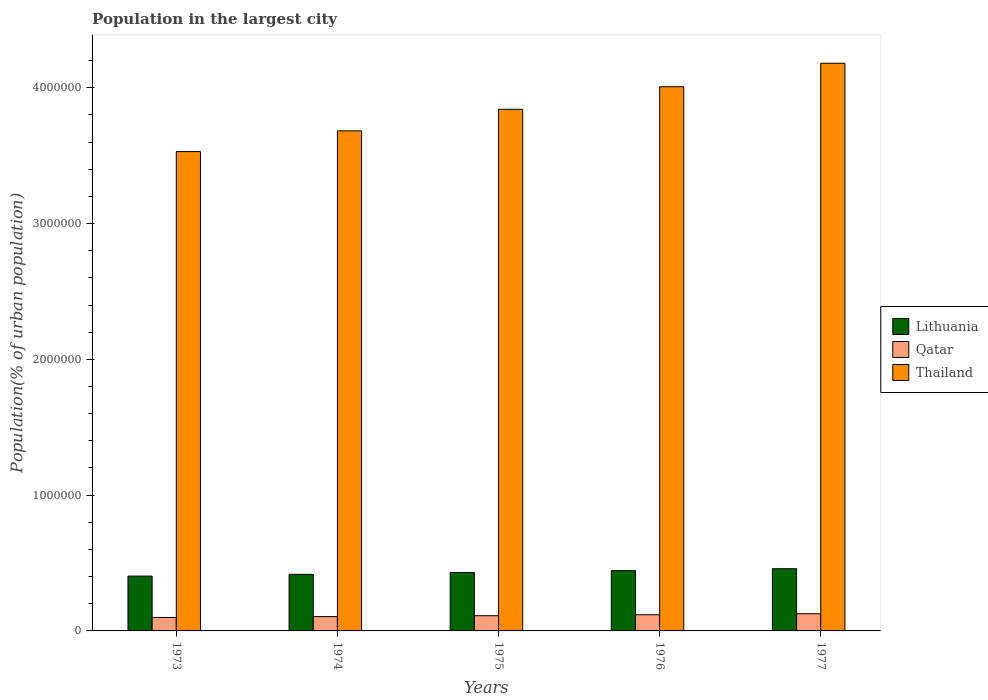How many groups of bars are there?
Keep it short and to the point. 5. Are the number of bars per tick equal to the number of legend labels?
Offer a very short reply. Yes. How many bars are there on the 3rd tick from the right?
Offer a terse response. 3. What is the label of the 4th group of bars from the left?
Provide a succinct answer. 1976. What is the population in the largest city in Qatar in 1974?
Ensure brevity in your answer.  1.05e+05. Across all years, what is the maximum population in the largest city in Lithuania?
Your response must be concise. 4.58e+05. Across all years, what is the minimum population in the largest city in Thailand?
Keep it short and to the point. 3.53e+06. In which year was the population in the largest city in Lithuania maximum?
Keep it short and to the point. 1977. What is the total population in the largest city in Thailand in the graph?
Provide a short and direct response. 1.92e+07. What is the difference between the population in the largest city in Qatar in 1974 and that in 1977?
Provide a succinct answer. -2.15e+04. What is the difference between the population in the largest city in Thailand in 1975 and the population in the largest city in Lithuania in 1974?
Make the answer very short. 3.43e+06. What is the average population in the largest city in Qatar per year?
Give a very brief answer. 1.12e+05. In the year 1974, what is the difference between the population in the largest city in Qatar and population in the largest city in Lithuania?
Your answer should be compact. -3.12e+05. In how many years, is the population in the largest city in Lithuania greater than 1200000 %?
Provide a short and direct response. 0. What is the ratio of the population in the largest city in Thailand in 1975 to that in 1977?
Make the answer very short. 0.92. Is the difference between the population in the largest city in Qatar in 1975 and 1976 greater than the difference between the population in the largest city in Lithuania in 1975 and 1976?
Provide a succinct answer. Yes. What is the difference between the highest and the second highest population in the largest city in Lithuania?
Your response must be concise. 1.42e+04. What is the difference between the highest and the lowest population in the largest city in Thailand?
Ensure brevity in your answer.  6.51e+05. In how many years, is the population in the largest city in Lithuania greater than the average population in the largest city in Lithuania taken over all years?
Ensure brevity in your answer.  2. Is the sum of the population in the largest city in Qatar in 1974 and 1976 greater than the maximum population in the largest city in Lithuania across all years?
Offer a very short reply. No. What does the 2nd bar from the left in 1975 represents?
Your answer should be compact. Qatar. What does the 2nd bar from the right in 1974 represents?
Offer a terse response. Qatar. Is it the case that in every year, the sum of the population in the largest city in Qatar and population in the largest city in Thailand is greater than the population in the largest city in Lithuania?
Make the answer very short. Yes. How many years are there in the graph?
Keep it short and to the point. 5. Are the values on the major ticks of Y-axis written in scientific E-notation?
Make the answer very short. No. Where does the legend appear in the graph?
Keep it short and to the point. Center right. How many legend labels are there?
Provide a short and direct response. 3. What is the title of the graph?
Your response must be concise. Population in the largest city. Does "Greece" appear as one of the legend labels in the graph?
Offer a terse response. No. What is the label or title of the X-axis?
Ensure brevity in your answer.  Years. What is the label or title of the Y-axis?
Keep it short and to the point. Population(% of urban population). What is the Population(% of urban population) in Lithuania in 1973?
Make the answer very short. 4.04e+05. What is the Population(% of urban population) in Qatar in 1973?
Provide a succinct answer. 9.90e+04. What is the Population(% of urban population) of Thailand in 1973?
Your answer should be compact. 3.53e+06. What is the Population(% of urban population) in Lithuania in 1974?
Your answer should be compact. 4.17e+05. What is the Population(% of urban population) of Qatar in 1974?
Provide a short and direct response. 1.05e+05. What is the Population(% of urban population) in Thailand in 1974?
Provide a short and direct response. 3.68e+06. What is the Population(% of urban population) in Lithuania in 1975?
Offer a very short reply. 4.30e+05. What is the Population(% of urban population) in Qatar in 1975?
Offer a terse response. 1.12e+05. What is the Population(% of urban population) in Thailand in 1975?
Your answer should be very brief. 3.84e+06. What is the Population(% of urban population) of Lithuania in 1976?
Ensure brevity in your answer.  4.44e+05. What is the Population(% of urban population) of Qatar in 1976?
Provide a short and direct response. 1.19e+05. What is the Population(% of urban population) of Thailand in 1976?
Ensure brevity in your answer.  4.01e+06. What is the Population(% of urban population) in Lithuania in 1977?
Keep it short and to the point. 4.58e+05. What is the Population(% of urban population) of Qatar in 1977?
Your answer should be very brief. 1.27e+05. What is the Population(% of urban population) of Thailand in 1977?
Your answer should be compact. 4.18e+06. Across all years, what is the maximum Population(% of urban population) of Lithuania?
Your response must be concise. 4.58e+05. Across all years, what is the maximum Population(% of urban population) of Qatar?
Provide a short and direct response. 1.27e+05. Across all years, what is the maximum Population(% of urban population) of Thailand?
Offer a terse response. 4.18e+06. Across all years, what is the minimum Population(% of urban population) of Lithuania?
Give a very brief answer. 4.04e+05. Across all years, what is the minimum Population(% of urban population) of Qatar?
Your answer should be compact. 9.90e+04. Across all years, what is the minimum Population(% of urban population) in Thailand?
Give a very brief answer. 3.53e+06. What is the total Population(% of urban population) of Lithuania in the graph?
Your answer should be very brief. 2.15e+06. What is the total Population(% of urban population) in Qatar in the graph?
Your answer should be compact. 5.62e+05. What is the total Population(% of urban population) of Thailand in the graph?
Keep it short and to the point. 1.92e+07. What is the difference between the Population(% of urban population) of Lithuania in 1973 and that in 1974?
Keep it short and to the point. -1.29e+04. What is the difference between the Population(% of urban population) of Qatar in 1973 and that in 1974?
Provide a succinct answer. -6317. What is the difference between the Population(% of urban population) in Thailand in 1973 and that in 1974?
Offer a terse response. -1.52e+05. What is the difference between the Population(% of urban population) of Lithuania in 1973 and that in 1975?
Provide a succinct answer. -2.62e+04. What is the difference between the Population(% of urban population) of Qatar in 1973 and that in 1975?
Make the answer very short. -1.30e+04. What is the difference between the Population(% of urban population) in Thailand in 1973 and that in 1975?
Make the answer very short. -3.12e+05. What is the difference between the Population(% of urban population) of Lithuania in 1973 and that in 1976?
Ensure brevity in your answer.  -4.00e+04. What is the difference between the Population(% of urban population) of Qatar in 1973 and that in 1976?
Make the answer very short. -2.02e+04. What is the difference between the Population(% of urban population) of Thailand in 1973 and that in 1976?
Your response must be concise. -4.78e+05. What is the difference between the Population(% of urban population) in Lithuania in 1973 and that in 1977?
Provide a succinct answer. -5.41e+04. What is the difference between the Population(% of urban population) of Qatar in 1973 and that in 1977?
Keep it short and to the point. -2.78e+04. What is the difference between the Population(% of urban population) in Thailand in 1973 and that in 1977?
Keep it short and to the point. -6.51e+05. What is the difference between the Population(% of urban population) in Lithuania in 1974 and that in 1975?
Keep it short and to the point. -1.33e+04. What is the difference between the Population(% of urban population) in Qatar in 1974 and that in 1975?
Your answer should be compact. -6721. What is the difference between the Population(% of urban population) of Thailand in 1974 and that in 1975?
Keep it short and to the point. -1.59e+05. What is the difference between the Population(% of urban population) in Lithuania in 1974 and that in 1976?
Provide a succinct answer. -2.71e+04. What is the difference between the Population(% of urban population) in Qatar in 1974 and that in 1976?
Ensure brevity in your answer.  -1.39e+04. What is the difference between the Population(% of urban population) of Thailand in 1974 and that in 1976?
Your answer should be very brief. -3.25e+05. What is the difference between the Population(% of urban population) of Lithuania in 1974 and that in 1977?
Provide a succinct answer. -4.12e+04. What is the difference between the Population(% of urban population) in Qatar in 1974 and that in 1977?
Provide a short and direct response. -2.15e+04. What is the difference between the Population(% of urban population) of Thailand in 1974 and that in 1977?
Offer a very short reply. -4.98e+05. What is the difference between the Population(% of urban population) in Lithuania in 1975 and that in 1976?
Your response must be concise. -1.38e+04. What is the difference between the Population(% of urban population) of Qatar in 1975 and that in 1976?
Your response must be concise. -7160. What is the difference between the Population(% of urban population) in Thailand in 1975 and that in 1976?
Your response must be concise. -1.66e+05. What is the difference between the Population(% of urban population) of Lithuania in 1975 and that in 1977?
Offer a terse response. -2.79e+04. What is the difference between the Population(% of urban population) in Qatar in 1975 and that in 1977?
Your response must be concise. -1.48e+04. What is the difference between the Population(% of urban population) in Thailand in 1975 and that in 1977?
Make the answer very short. -3.39e+05. What is the difference between the Population(% of urban population) in Lithuania in 1976 and that in 1977?
Your response must be concise. -1.42e+04. What is the difference between the Population(% of urban population) in Qatar in 1976 and that in 1977?
Provide a short and direct response. -7596. What is the difference between the Population(% of urban population) of Thailand in 1976 and that in 1977?
Keep it short and to the point. -1.73e+05. What is the difference between the Population(% of urban population) of Lithuania in 1973 and the Population(% of urban population) of Qatar in 1974?
Offer a very short reply. 2.99e+05. What is the difference between the Population(% of urban population) in Lithuania in 1973 and the Population(% of urban population) in Thailand in 1974?
Provide a succinct answer. -3.28e+06. What is the difference between the Population(% of urban population) of Qatar in 1973 and the Population(% of urban population) of Thailand in 1974?
Provide a succinct answer. -3.58e+06. What is the difference between the Population(% of urban population) in Lithuania in 1973 and the Population(% of urban population) in Qatar in 1975?
Offer a very short reply. 2.92e+05. What is the difference between the Population(% of urban population) of Lithuania in 1973 and the Population(% of urban population) of Thailand in 1975?
Your answer should be very brief. -3.44e+06. What is the difference between the Population(% of urban population) in Qatar in 1973 and the Population(% of urban population) in Thailand in 1975?
Provide a short and direct response. -3.74e+06. What is the difference between the Population(% of urban population) in Lithuania in 1973 and the Population(% of urban population) in Qatar in 1976?
Ensure brevity in your answer.  2.85e+05. What is the difference between the Population(% of urban population) in Lithuania in 1973 and the Population(% of urban population) in Thailand in 1976?
Offer a very short reply. -3.60e+06. What is the difference between the Population(% of urban population) in Qatar in 1973 and the Population(% of urban population) in Thailand in 1976?
Offer a very short reply. -3.91e+06. What is the difference between the Population(% of urban population) in Lithuania in 1973 and the Population(% of urban population) in Qatar in 1977?
Ensure brevity in your answer.  2.77e+05. What is the difference between the Population(% of urban population) in Lithuania in 1973 and the Population(% of urban population) in Thailand in 1977?
Your answer should be very brief. -3.78e+06. What is the difference between the Population(% of urban population) of Qatar in 1973 and the Population(% of urban population) of Thailand in 1977?
Keep it short and to the point. -4.08e+06. What is the difference between the Population(% of urban population) in Lithuania in 1974 and the Population(% of urban population) in Qatar in 1975?
Ensure brevity in your answer.  3.05e+05. What is the difference between the Population(% of urban population) of Lithuania in 1974 and the Population(% of urban population) of Thailand in 1975?
Make the answer very short. -3.43e+06. What is the difference between the Population(% of urban population) of Qatar in 1974 and the Population(% of urban population) of Thailand in 1975?
Keep it short and to the point. -3.74e+06. What is the difference between the Population(% of urban population) in Lithuania in 1974 and the Population(% of urban population) in Qatar in 1976?
Keep it short and to the point. 2.98e+05. What is the difference between the Population(% of urban population) in Lithuania in 1974 and the Population(% of urban population) in Thailand in 1976?
Your response must be concise. -3.59e+06. What is the difference between the Population(% of urban population) in Qatar in 1974 and the Population(% of urban population) in Thailand in 1976?
Your answer should be compact. -3.90e+06. What is the difference between the Population(% of urban population) in Lithuania in 1974 and the Population(% of urban population) in Qatar in 1977?
Make the answer very short. 2.90e+05. What is the difference between the Population(% of urban population) in Lithuania in 1974 and the Population(% of urban population) in Thailand in 1977?
Ensure brevity in your answer.  -3.76e+06. What is the difference between the Population(% of urban population) of Qatar in 1974 and the Population(% of urban population) of Thailand in 1977?
Make the answer very short. -4.08e+06. What is the difference between the Population(% of urban population) of Lithuania in 1975 and the Population(% of urban population) of Qatar in 1976?
Your response must be concise. 3.11e+05. What is the difference between the Population(% of urban population) in Lithuania in 1975 and the Population(% of urban population) in Thailand in 1976?
Give a very brief answer. -3.58e+06. What is the difference between the Population(% of urban population) in Qatar in 1975 and the Population(% of urban population) in Thailand in 1976?
Provide a short and direct response. -3.90e+06. What is the difference between the Population(% of urban population) in Lithuania in 1975 and the Population(% of urban population) in Qatar in 1977?
Give a very brief answer. 3.03e+05. What is the difference between the Population(% of urban population) of Lithuania in 1975 and the Population(% of urban population) of Thailand in 1977?
Offer a terse response. -3.75e+06. What is the difference between the Population(% of urban population) of Qatar in 1975 and the Population(% of urban population) of Thailand in 1977?
Keep it short and to the point. -4.07e+06. What is the difference between the Population(% of urban population) in Lithuania in 1976 and the Population(% of urban population) in Qatar in 1977?
Make the answer very short. 3.17e+05. What is the difference between the Population(% of urban population) of Lithuania in 1976 and the Population(% of urban population) of Thailand in 1977?
Make the answer very short. -3.74e+06. What is the difference between the Population(% of urban population) of Qatar in 1976 and the Population(% of urban population) of Thailand in 1977?
Ensure brevity in your answer.  -4.06e+06. What is the average Population(% of urban population) of Lithuania per year?
Make the answer very short. 4.31e+05. What is the average Population(% of urban population) in Qatar per year?
Your response must be concise. 1.12e+05. What is the average Population(% of urban population) of Thailand per year?
Your response must be concise. 3.85e+06. In the year 1973, what is the difference between the Population(% of urban population) in Lithuania and Population(% of urban population) in Qatar?
Ensure brevity in your answer.  3.05e+05. In the year 1973, what is the difference between the Population(% of urban population) in Lithuania and Population(% of urban population) in Thailand?
Your answer should be compact. -3.13e+06. In the year 1973, what is the difference between the Population(% of urban population) in Qatar and Population(% of urban population) in Thailand?
Offer a very short reply. -3.43e+06. In the year 1974, what is the difference between the Population(% of urban population) in Lithuania and Population(% of urban population) in Qatar?
Offer a very short reply. 3.12e+05. In the year 1974, what is the difference between the Population(% of urban population) of Lithuania and Population(% of urban population) of Thailand?
Offer a very short reply. -3.27e+06. In the year 1974, what is the difference between the Population(% of urban population) in Qatar and Population(% of urban population) in Thailand?
Offer a very short reply. -3.58e+06. In the year 1975, what is the difference between the Population(% of urban population) of Lithuania and Population(% of urban population) of Qatar?
Keep it short and to the point. 3.18e+05. In the year 1975, what is the difference between the Population(% of urban population) in Lithuania and Population(% of urban population) in Thailand?
Provide a short and direct response. -3.41e+06. In the year 1975, what is the difference between the Population(% of urban population) in Qatar and Population(% of urban population) in Thailand?
Provide a succinct answer. -3.73e+06. In the year 1976, what is the difference between the Population(% of urban population) in Lithuania and Population(% of urban population) in Qatar?
Your answer should be very brief. 3.25e+05. In the year 1976, what is the difference between the Population(% of urban population) of Lithuania and Population(% of urban population) of Thailand?
Your answer should be compact. -3.56e+06. In the year 1976, what is the difference between the Population(% of urban population) in Qatar and Population(% of urban population) in Thailand?
Your response must be concise. -3.89e+06. In the year 1977, what is the difference between the Population(% of urban population) of Lithuania and Population(% of urban population) of Qatar?
Ensure brevity in your answer.  3.31e+05. In the year 1977, what is the difference between the Population(% of urban population) in Lithuania and Population(% of urban population) in Thailand?
Offer a very short reply. -3.72e+06. In the year 1977, what is the difference between the Population(% of urban population) in Qatar and Population(% of urban population) in Thailand?
Keep it short and to the point. -4.05e+06. What is the ratio of the Population(% of urban population) of Qatar in 1973 to that in 1974?
Your response must be concise. 0.94. What is the ratio of the Population(% of urban population) of Thailand in 1973 to that in 1974?
Your answer should be very brief. 0.96. What is the ratio of the Population(% of urban population) in Lithuania in 1973 to that in 1975?
Your answer should be compact. 0.94. What is the ratio of the Population(% of urban population) of Qatar in 1973 to that in 1975?
Give a very brief answer. 0.88. What is the ratio of the Population(% of urban population) in Thailand in 1973 to that in 1975?
Your answer should be very brief. 0.92. What is the ratio of the Population(% of urban population) of Lithuania in 1973 to that in 1976?
Your answer should be compact. 0.91. What is the ratio of the Population(% of urban population) of Qatar in 1973 to that in 1976?
Your answer should be very brief. 0.83. What is the ratio of the Population(% of urban population) of Thailand in 1973 to that in 1976?
Make the answer very short. 0.88. What is the ratio of the Population(% of urban population) in Lithuania in 1973 to that in 1977?
Your response must be concise. 0.88. What is the ratio of the Population(% of urban population) of Qatar in 1973 to that in 1977?
Keep it short and to the point. 0.78. What is the ratio of the Population(% of urban population) in Thailand in 1973 to that in 1977?
Make the answer very short. 0.84. What is the ratio of the Population(% of urban population) of Qatar in 1974 to that in 1975?
Your answer should be compact. 0.94. What is the ratio of the Population(% of urban population) in Thailand in 1974 to that in 1975?
Offer a very short reply. 0.96. What is the ratio of the Population(% of urban population) in Lithuania in 1974 to that in 1976?
Your answer should be compact. 0.94. What is the ratio of the Population(% of urban population) of Qatar in 1974 to that in 1976?
Keep it short and to the point. 0.88. What is the ratio of the Population(% of urban population) in Thailand in 1974 to that in 1976?
Offer a terse response. 0.92. What is the ratio of the Population(% of urban population) in Lithuania in 1974 to that in 1977?
Make the answer very short. 0.91. What is the ratio of the Population(% of urban population) in Qatar in 1974 to that in 1977?
Provide a succinct answer. 0.83. What is the ratio of the Population(% of urban population) in Thailand in 1974 to that in 1977?
Your answer should be compact. 0.88. What is the ratio of the Population(% of urban population) in Lithuania in 1975 to that in 1976?
Provide a succinct answer. 0.97. What is the ratio of the Population(% of urban population) in Qatar in 1975 to that in 1976?
Make the answer very short. 0.94. What is the ratio of the Population(% of urban population) in Thailand in 1975 to that in 1976?
Provide a succinct answer. 0.96. What is the ratio of the Population(% of urban population) of Lithuania in 1975 to that in 1977?
Provide a succinct answer. 0.94. What is the ratio of the Population(% of urban population) in Qatar in 1975 to that in 1977?
Your answer should be very brief. 0.88. What is the ratio of the Population(% of urban population) in Thailand in 1975 to that in 1977?
Offer a terse response. 0.92. What is the ratio of the Population(% of urban population) of Lithuania in 1976 to that in 1977?
Your response must be concise. 0.97. What is the ratio of the Population(% of urban population) of Qatar in 1976 to that in 1977?
Offer a very short reply. 0.94. What is the ratio of the Population(% of urban population) in Thailand in 1976 to that in 1977?
Ensure brevity in your answer.  0.96. What is the difference between the highest and the second highest Population(% of urban population) in Lithuania?
Keep it short and to the point. 1.42e+04. What is the difference between the highest and the second highest Population(% of urban population) of Qatar?
Make the answer very short. 7596. What is the difference between the highest and the second highest Population(% of urban population) of Thailand?
Make the answer very short. 1.73e+05. What is the difference between the highest and the lowest Population(% of urban population) in Lithuania?
Give a very brief answer. 5.41e+04. What is the difference between the highest and the lowest Population(% of urban population) in Qatar?
Ensure brevity in your answer.  2.78e+04. What is the difference between the highest and the lowest Population(% of urban population) in Thailand?
Your response must be concise. 6.51e+05. 